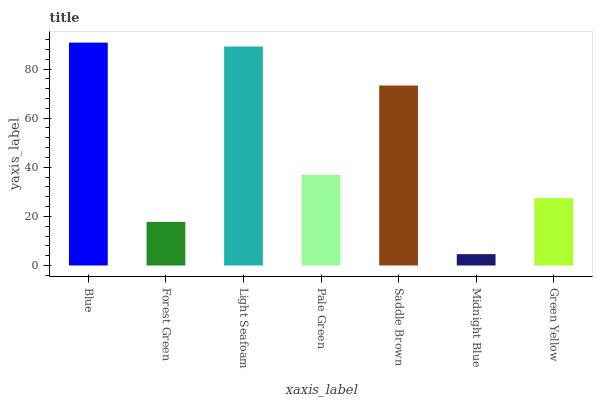Is Midnight Blue the minimum?
Answer yes or no. Yes. Is Blue the maximum?
Answer yes or no. Yes. Is Forest Green the minimum?
Answer yes or no. No. Is Forest Green the maximum?
Answer yes or no. No. Is Blue greater than Forest Green?
Answer yes or no. Yes. Is Forest Green less than Blue?
Answer yes or no. Yes. Is Forest Green greater than Blue?
Answer yes or no. No. Is Blue less than Forest Green?
Answer yes or no. No. Is Pale Green the high median?
Answer yes or no. Yes. Is Pale Green the low median?
Answer yes or no. Yes. Is Green Yellow the high median?
Answer yes or no. No. Is Saddle Brown the low median?
Answer yes or no. No. 